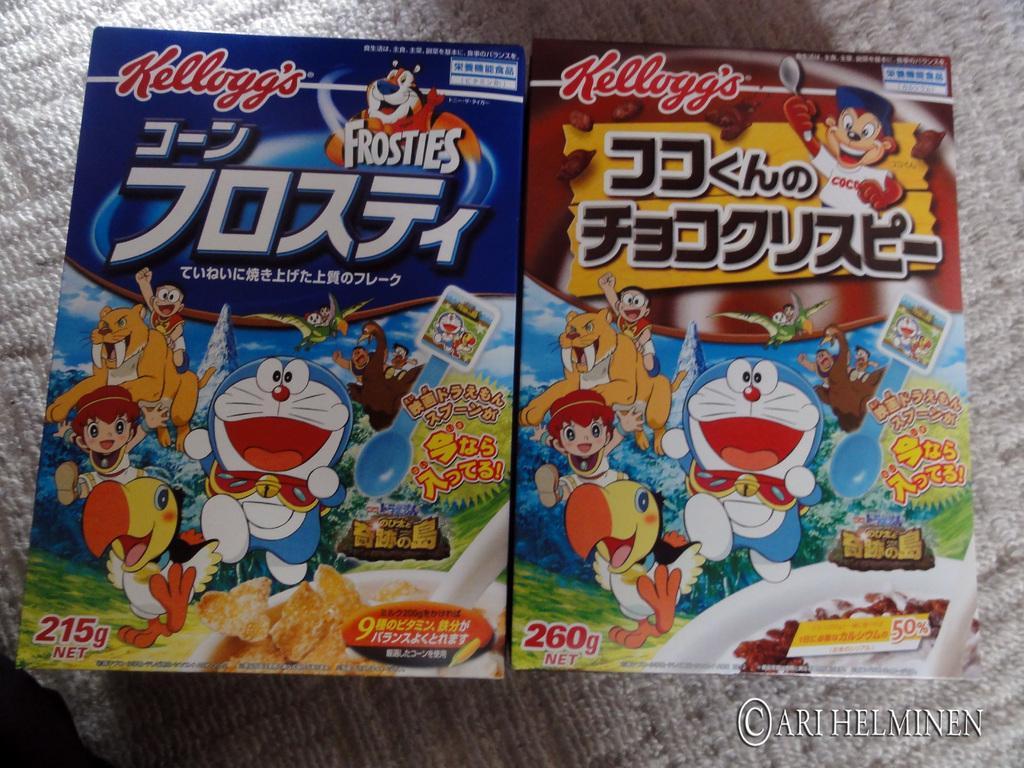How would you summarize this image in a sentence or two? In this image there might be covers kept on the floor and on the covers there is a text, cartoon images of animals, persons, balloons, trees, numbers, food item visible. 